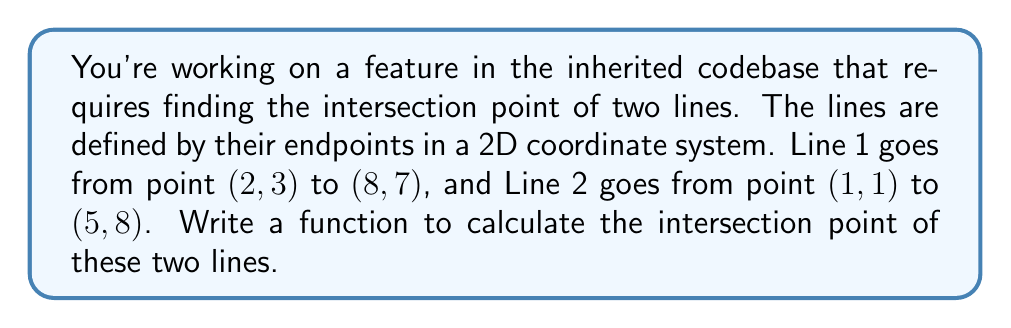Give your solution to this math problem. To solve this problem, we'll follow these steps:

1) First, we need to express each line in the form $y = mx + b$, where $m$ is the slope and $b$ is the y-intercept.

2) For Line 1:
   $m_1 = \frac{y_2 - y_1}{x_2 - x_1} = \frac{7 - 3}{8 - 2} = \frac{2}{3}$
   Using point (2, 3): $3 = \frac{2}{3}(2) + b_1$, so $b_1 = 3 - \frac{4}{3} = \frac{5}{3}$
   Line 1 equation: $y = \frac{2}{3}x + \frac{5}{3}$

3) For Line 2:
   $m_2 = \frac{8 - 1}{5 - 1} = \frac{7}{4}$
   Using point (1, 1): $1 = \frac{7}{4}(1) + b_2$, so $b_2 = 1 - \frac{7}{4} = -\frac{3}{4}$
   Line 2 equation: $y = \frac{7}{4}x - \frac{3}{4}$

4) At the intersection point, the x and y coordinates will be the same for both lines. So we can set the right sides of the equations equal to each other:

   $$\frac{2}{3}x + \frac{5}{3} = \frac{7}{4}x - \frac{3}{4}$$

5) Solve for x:
   $$\frac{2}{3}x - \frac{7}{4}x = -\frac{3}{4} - \frac{5}{3}$$
   $$\frac{8}{12}x - \frac{21}{12}x = -\frac{9}{12} - \frac{20}{12}$$
   $$-\frac{13}{12}x = -\frac{29}{12}$$
   $$x = \frac{29}{13} \approx 2.23$$

6) Substitute this x value back into either line equation to find y:
   $$y = \frac{2}{3}(\frac{29}{13}) + \frac{5}{3} = \frac{58}{39} + \frac{65}{39} = \frac{123}{39} \approx 3.15$$

Therefore, the intersection point is approximately (2.23, 3.15).
Answer: The intersection point of the two lines is $(\frac{29}{13}, \frac{123}{39})$, or approximately (2.23, 3.15). 